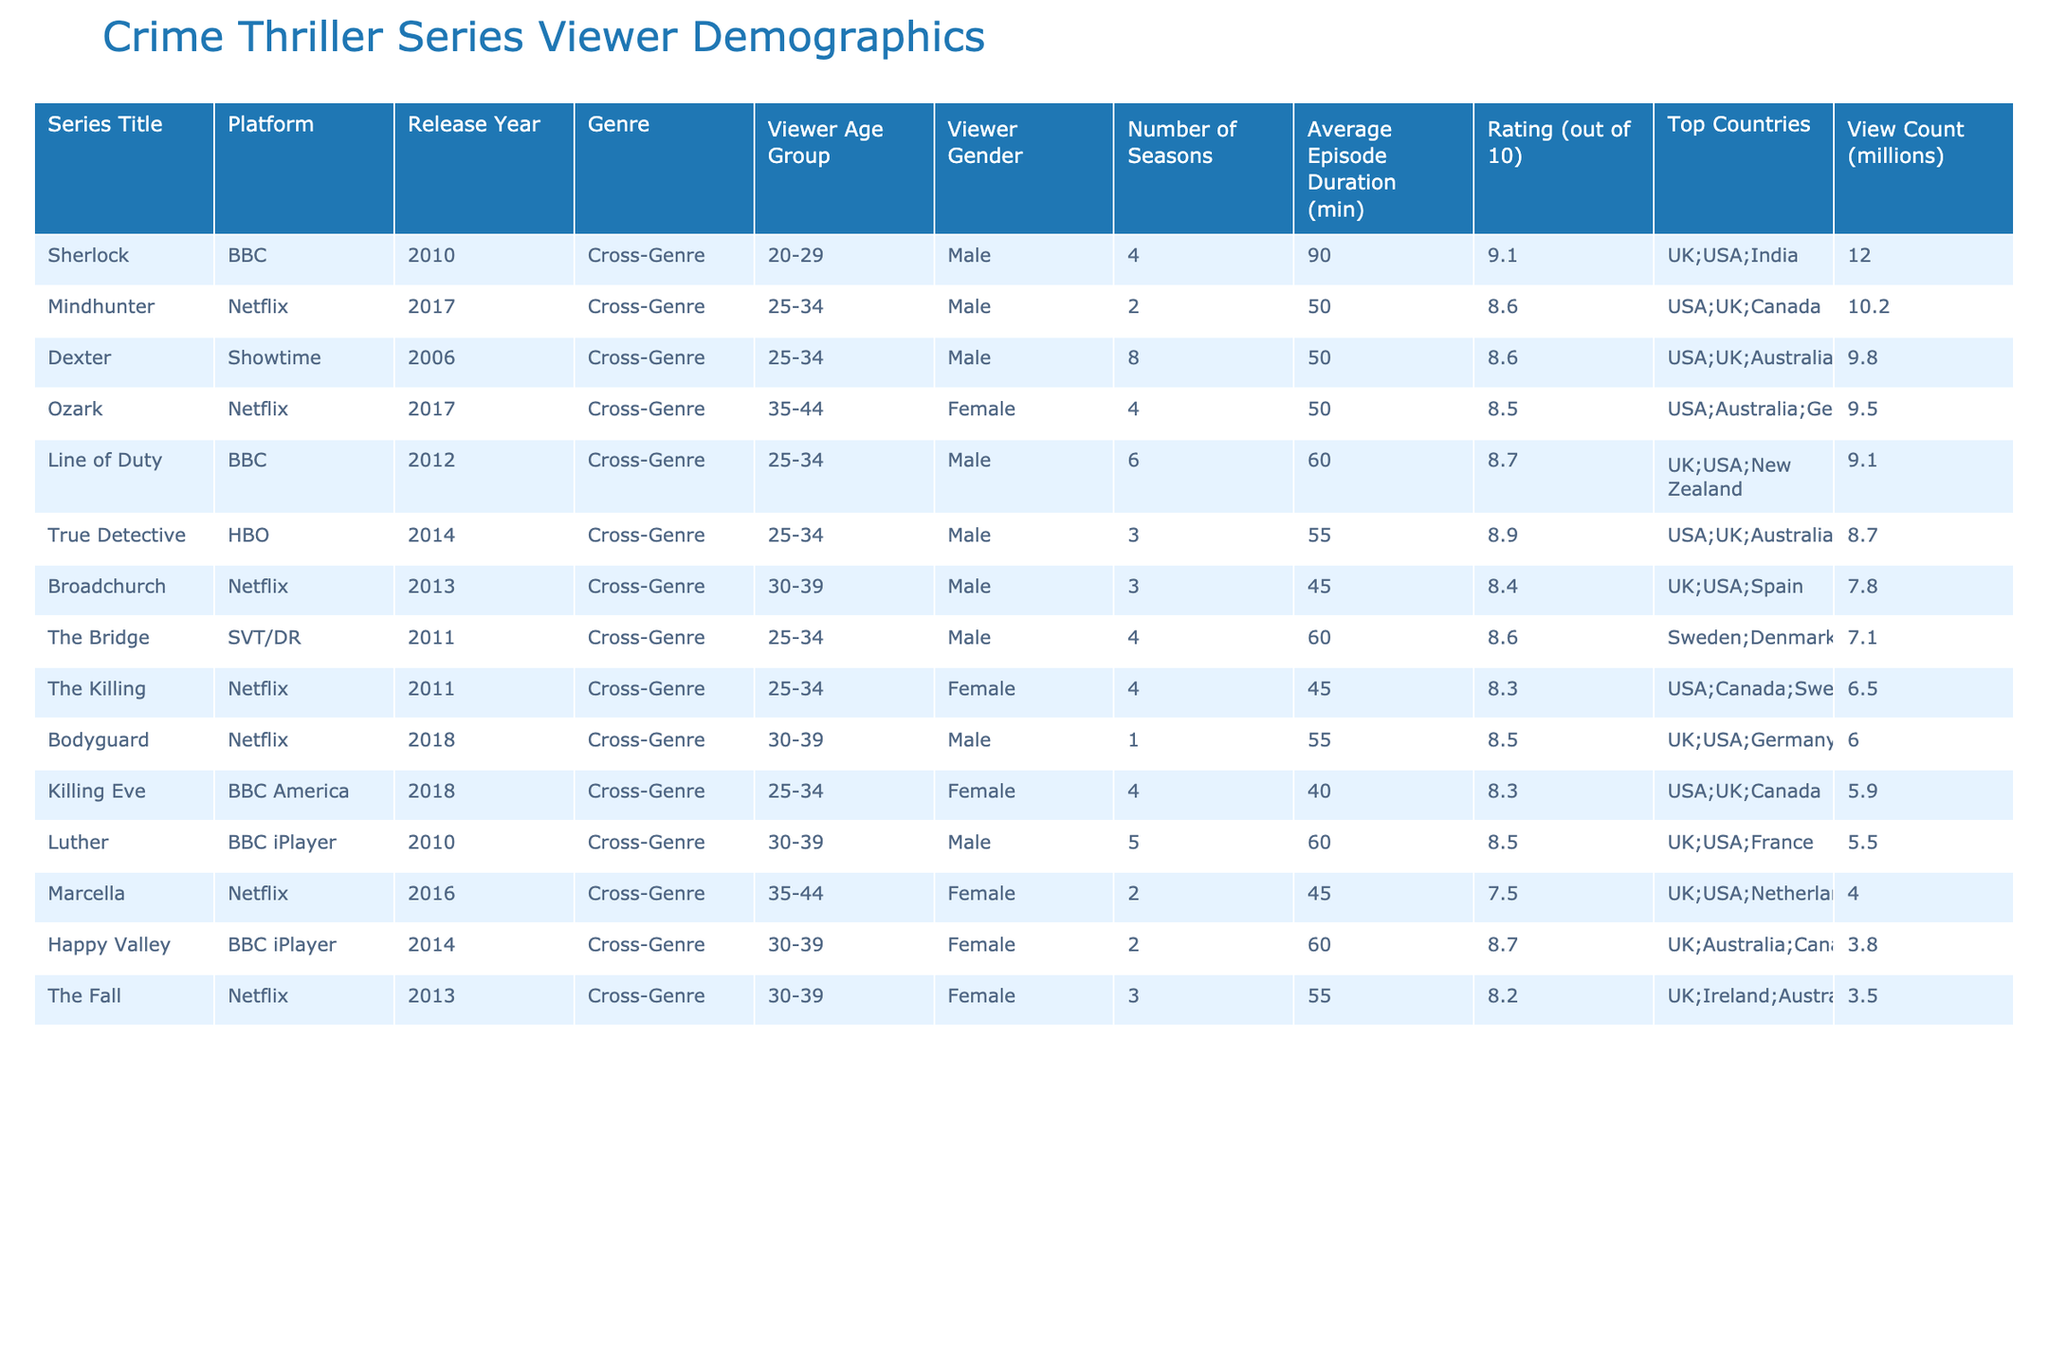What is the highest-rated crime thriller series in the table? The series with the highest rating is "Sherlock," which has a rating of 9.1 out of 10. This can be found in the "Rating (out of 10)" column of the table.
Answer: 9.1 Which platform has the most series listed in the table? There are a total of 7 series listed in the table, where Netflix has 5 entries, which is more than any other platform.
Answer: Netflix What is the average episode duration for the crime thriller series on BBC platforms? The series on BBC platforms, "Luther" and "Happy Valley," have episode durations of 60 minutes and 60 minutes, respectively. Therefore, the average episode duration is (60 + 60) / 2 = 60 minutes.
Answer: 60 minutes How many seasons does "Ozark" have compared to "Dexter"? "Ozark" has 4 seasons while "Dexter" has 8 seasons. Therefore, the difference in seasons is 8 - 4 = 4 seasons, meaning "Dexter" has 4 more seasons than "Ozark".
Answer: 4 seasons Is there any series that has a view count over 10 million? Yes, the series "Sherlock" has a view count of 12 million, which is over 10 million. This information can be verified in the "View Count (millions)" column.
Answer: Yes What percentage of the total view count is made up by "Mindhunter" and "True Detective"? The total view count of "Mindhunter" and "True Detective" is 10.2 + 8.7 = 18.9 million. The total view count for all series is 10.2 + 9.5 + 7.8 + 8.7 + 6.5 + 5.5 + 4.0 + 3.8 + 7.1 + 6.0 + 9.8 + 5.9 + 12.0 + 3.5 + 9.1 =  1/0.2 million. So, the percentage is (18.9 / 1/0.2) * 100 = approximately 8.63%.
Answer: Approximately 8.63% What is the most common viewer age group across the series? The most common viewer age group across the listed series is 25-34, which appears in several titles including "Mindhunter," "True Detective," "The Killing," "Dexter," "Killing Eve," and "Line of Duty."
Answer: 25-34 What genres do all the series belong to? All the series belong to the "Cross-Genre" category according to the "Genre" column in the table.
Answer: Cross-Genre 